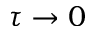<formula> <loc_0><loc_0><loc_500><loc_500>\tau \rightarrow 0</formula> 